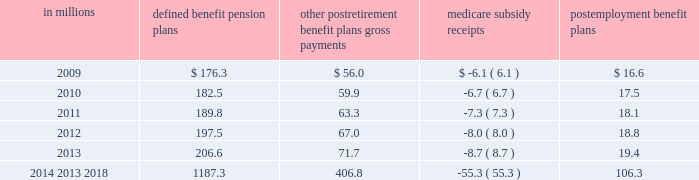Contributions and future benefit payments we expect to make contributions of $ 28.1 million to our defined benefit , other postretirement , and postemployment benefits plans in fiscal 2009 .
Actual 2009 contributions could exceed our current projections , as influenced by our decision to undertake discretionary funding of our benefit trusts versus other competing investment priorities and future changes in government requirements .
Estimated benefit payments , which reflect expected future service , as appropriate , are expected to be paid from fiscal 2009-2018 as follows : in millions defined benefit pension postretirement benefit plans gross payments medicare subsidy receipts postemployment benefit ......................................................................................................................................................................................... .
Defined contribution plans the general mills savings plan is a defined contribution plan that covers salaried and nonunion employees .
It had net assets of $ 2309.9 million as of may 25 , 2008 and $ 2303.0 million as of may 27 , 2007.this plan is a 401 ( k ) savings plan that includes a number of investment funds and an employee stock ownership plan ( esop ) .
We sponsor another savings plan for certain hourly employees with net assets of $ 16.0 million as of may 25 , 2008 .
Our total recognized expense related to defined contribution plans was $ 61.9 million in fiscal 2008 , $ 48.3 million in fiscal 2007 , and $ 45.5 million in fiscal 2006 .
The esop originally purchased our common stock principally with funds borrowed from third parties and guaranteed by us.the esop shares are included in net shares outstanding for the purposes of calculating eps .
The esop 2019s third-party debt was repaid on june 30 , 2007 .
The esop 2019s only assets are our common stock and temporary cash balances.the esop 2019s share of the total defined contribution expense was $ 52.3 million in fiscal 2008 , $ 40.1 million in fiscal 2007 , and $ 37.6 million in fiscal 2006 .
The esop 2019s expensewas calculated by the 201cshares allocated 201dmethod .
The esop used our common stock to convey benefits to employees and , through increased stock ownership , to further align employee interests with those of stockholders.wematched a percentage of employee contributions to the general mills savings plan with a base match plus a variable year end match that depended on annual results .
Employees received our match in the form of common stock .
Our cash contribution to the esop was calculated so as to pay off enough debt to release sufficient shares to make our match .
The esop used our cash contributions to the plan , plus the dividends received on the esop 2019s leveraged shares , to make principal and interest payments on the esop 2019s debt .
As loan payments were made , shares became unencumbered by debt and were committed to be allocated .
The esop allocated shares to individual employee accounts on the basis of the match of employee payroll savings ( contributions ) , plus reinvested dividends received on previously allocated shares .
The esop incurred net interest of less than $ 1.0 million in each of fiscal 2007 and 2006 .
The esop used dividends of $ 2.5 million in fiscal 2007 and $ 3.9 million in 2006 , along with our contributions of less than $ 1.0 million in each of fiscal 2007 and 2006 to make interest and principal payments .
The number of shares of our common stock allocated to participants in the esop was 5.2 million as of may 25 , 2008 , and 5.4 million as of may 27 , 2007 .
Annual report 2008 81 .
What is the change in net assets from 2007 to 2008? 
Computations: (2309.9 - 2303.0)
Answer: 6.9. 